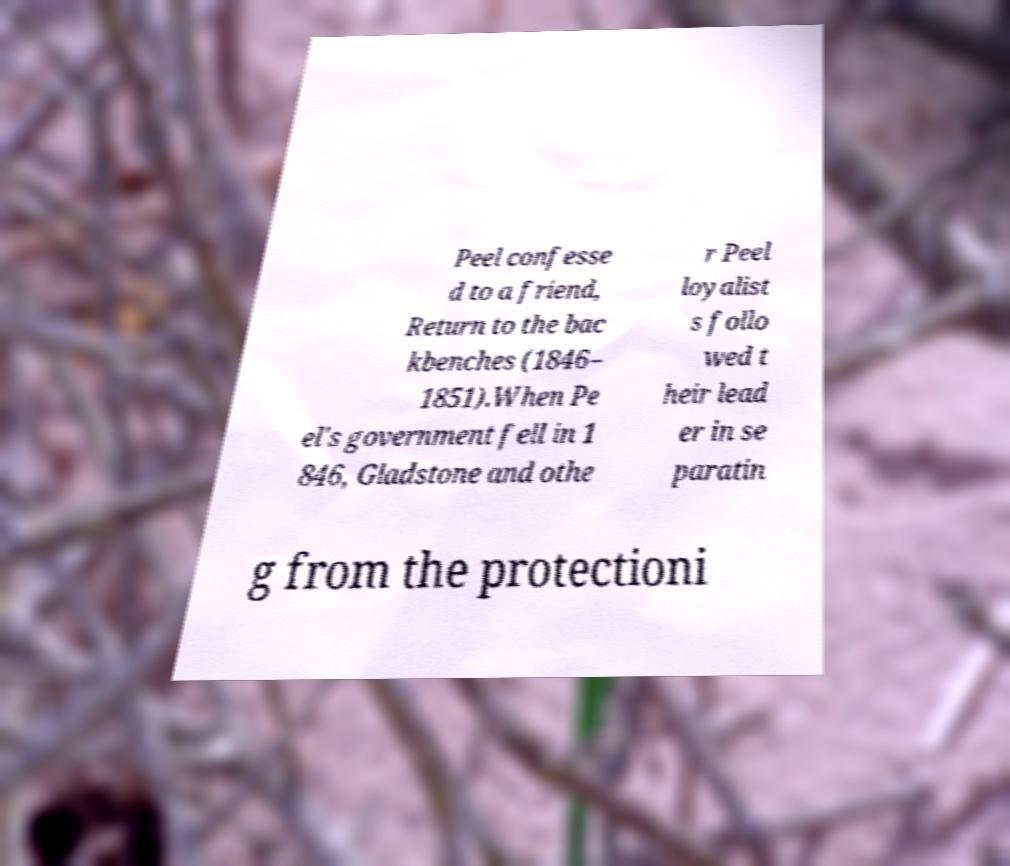Could you extract and type out the text from this image? Peel confesse d to a friend, Return to the bac kbenches (1846– 1851).When Pe el's government fell in 1 846, Gladstone and othe r Peel loyalist s follo wed t heir lead er in se paratin g from the protectioni 